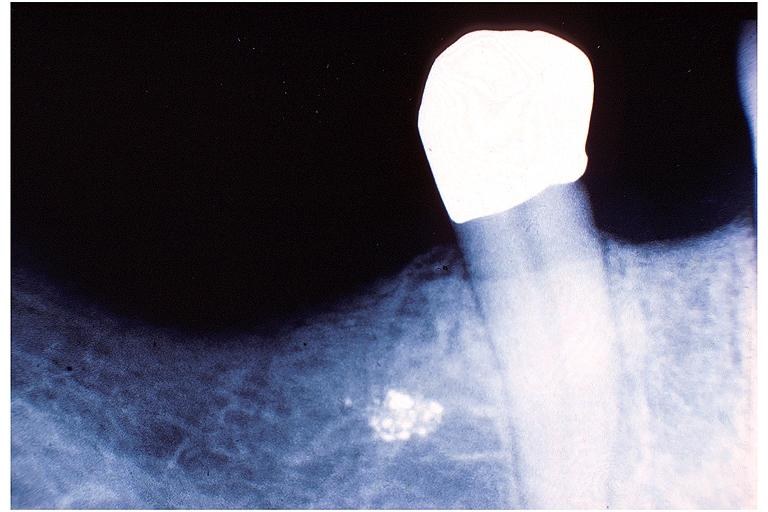does nuclear change show amalgam tattoo?
Answer the question using a single word or phrase. No 